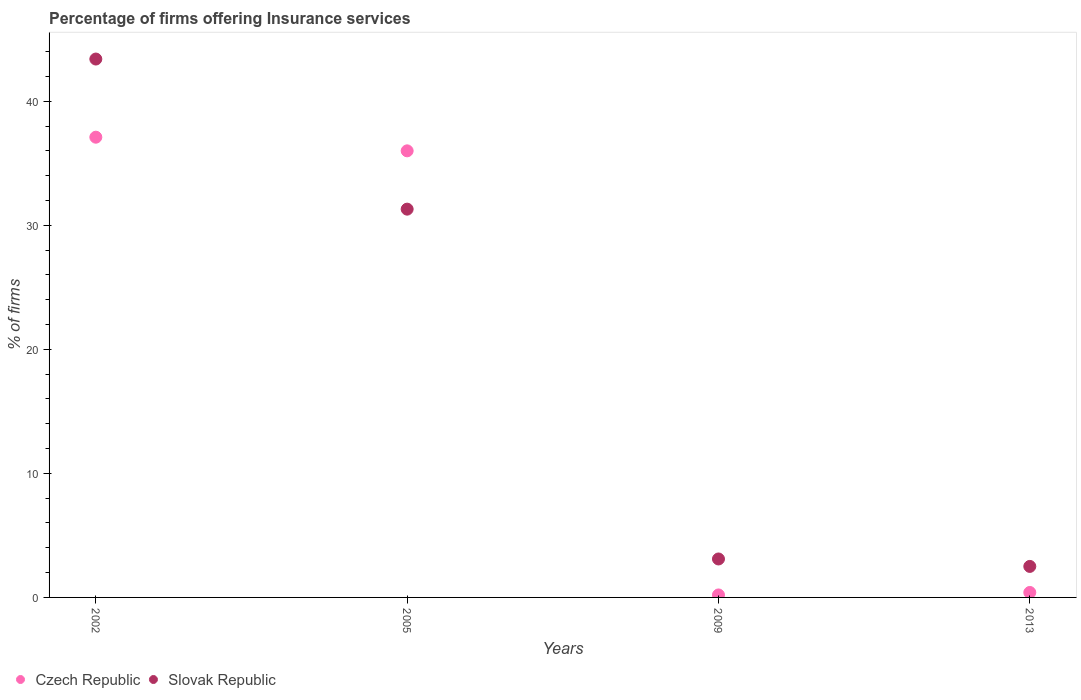Is the number of dotlines equal to the number of legend labels?
Ensure brevity in your answer.  Yes. What is the percentage of firms offering insurance services in Czech Republic in 2009?
Offer a terse response. 0.2. Across all years, what is the maximum percentage of firms offering insurance services in Czech Republic?
Make the answer very short. 37.1. Across all years, what is the minimum percentage of firms offering insurance services in Czech Republic?
Make the answer very short. 0.2. In which year was the percentage of firms offering insurance services in Czech Republic maximum?
Offer a terse response. 2002. What is the total percentage of firms offering insurance services in Slovak Republic in the graph?
Your answer should be very brief. 80.3. What is the difference between the percentage of firms offering insurance services in Slovak Republic in 2005 and the percentage of firms offering insurance services in Czech Republic in 2009?
Make the answer very short. 31.1. What is the average percentage of firms offering insurance services in Slovak Republic per year?
Provide a short and direct response. 20.07. In how many years, is the percentage of firms offering insurance services in Czech Republic greater than 20 %?
Offer a very short reply. 2. What is the ratio of the percentage of firms offering insurance services in Slovak Republic in 2002 to that in 2005?
Ensure brevity in your answer.  1.39. What is the difference between the highest and the second highest percentage of firms offering insurance services in Czech Republic?
Provide a short and direct response. 1.1. What is the difference between the highest and the lowest percentage of firms offering insurance services in Slovak Republic?
Ensure brevity in your answer.  40.9. In how many years, is the percentage of firms offering insurance services in Slovak Republic greater than the average percentage of firms offering insurance services in Slovak Republic taken over all years?
Offer a very short reply. 2. Is the sum of the percentage of firms offering insurance services in Slovak Republic in 2009 and 2013 greater than the maximum percentage of firms offering insurance services in Czech Republic across all years?
Keep it short and to the point. No. Does the percentage of firms offering insurance services in Slovak Republic monotonically increase over the years?
Give a very brief answer. No. Is the percentage of firms offering insurance services in Czech Republic strictly less than the percentage of firms offering insurance services in Slovak Republic over the years?
Provide a short and direct response. No. Does the graph contain any zero values?
Ensure brevity in your answer.  No. Does the graph contain grids?
Offer a terse response. No. How many legend labels are there?
Provide a succinct answer. 2. What is the title of the graph?
Provide a succinct answer. Percentage of firms offering Insurance services. What is the label or title of the X-axis?
Your answer should be compact. Years. What is the label or title of the Y-axis?
Provide a succinct answer. % of firms. What is the % of firms of Czech Republic in 2002?
Provide a short and direct response. 37.1. What is the % of firms of Slovak Republic in 2002?
Offer a very short reply. 43.4. What is the % of firms of Slovak Republic in 2005?
Your answer should be very brief. 31.3. What is the % of firms in Czech Republic in 2009?
Provide a succinct answer. 0.2. What is the % of firms in Slovak Republic in 2009?
Provide a short and direct response. 3.1. What is the % of firms of Slovak Republic in 2013?
Offer a terse response. 2.5. Across all years, what is the maximum % of firms of Czech Republic?
Provide a short and direct response. 37.1. Across all years, what is the maximum % of firms in Slovak Republic?
Ensure brevity in your answer.  43.4. Across all years, what is the minimum % of firms of Slovak Republic?
Provide a succinct answer. 2.5. What is the total % of firms of Czech Republic in the graph?
Your answer should be compact. 73.7. What is the total % of firms in Slovak Republic in the graph?
Your answer should be compact. 80.3. What is the difference between the % of firms of Slovak Republic in 2002 and that in 2005?
Your answer should be compact. 12.1. What is the difference between the % of firms in Czech Republic in 2002 and that in 2009?
Your answer should be compact. 36.9. What is the difference between the % of firms of Slovak Republic in 2002 and that in 2009?
Provide a short and direct response. 40.3. What is the difference between the % of firms of Czech Republic in 2002 and that in 2013?
Offer a terse response. 36.7. What is the difference between the % of firms in Slovak Republic in 2002 and that in 2013?
Ensure brevity in your answer.  40.9. What is the difference between the % of firms of Czech Republic in 2005 and that in 2009?
Provide a succinct answer. 35.8. What is the difference between the % of firms in Slovak Republic in 2005 and that in 2009?
Your answer should be compact. 28.2. What is the difference between the % of firms in Czech Republic in 2005 and that in 2013?
Provide a succinct answer. 35.6. What is the difference between the % of firms in Slovak Republic in 2005 and that in 2013?
Provide a succinct answer. 28.8. What is the difference between the % of firms in Czech Republic in 2002 and the % of firms in Slovak Republic in 2005?
Your answer should be very brief. 5.8. What is the difference between the % of firms of Czech Republic in 2002 and the % of firms of Slovak Republic in 2009?
Your response must be concise. 34. What is the difference between the % of firms of Czech Republic in 2002 and the % of firms of Slovak Republic in 2013?
Offer a very short reply. 34.6. What is the difference between the % of firms of Czech Republic in 2005 and the % of firms of Slovak Republic in 2009?
Offer a terse response. 32.9. What is the difference between the % of firms in Czech Republic in 2005 and the % of firms in Slovak Republic in 2013?
Give a very brief answer. 33.5. What is the average % of firms in Czech Republic per year?
Your answer should be compact. 18.43. What is the average % of firms of Slovak Republic per year?
Your answer should be very brief. 20.07. In the year 2002, what is the difference between the % of firms in Czech Republic and % of firms in Slovak Republic?
Offer a very short reply. -6.3. What is the ratio of the % of firms in Czech Republic in 2002 to that in 2005?
Your response must be concise. 1.03. What is the ratio of the % of firms of Slovak Republic in 2002 to that in 2005?
Provide a succinct answer. 1.39. What is the ratio of the % of firms in Czech Republic in 2002 to that in 2009?
Ensure brevity in your answer.  185.5. What is the ratio of the % of firms in Slovak Republic in 2002 to that in 2009?
Provide a succinct answer. 14. What is the ratio of the % of firms of Czech Republic in 2002 to that in 2013?
Keep it short and to the point. 92.75. What is the ratio of the % of firms in Slovak Republic in 2002 to that in 2013?
Provide a short and direct response. 17.36. What is the ratio of the % of firms of Czech Republic in 2005 to that in 2009?
Keep it short and to the point. 180. What is the ratio of the % of firms in Slovak Republic in 2005 to that in 2009?
Give a very brief answer. 10.1. What is the ratio of the % of firms in Czech Republic in 2005 to that in 2013?
Your response must be concise. 90. What is the ratio of the % of firms of Slovak Republic in 2005 to that in 2013?
Offer a terse response. 12.52. What is the ratio of the % of firms of Slovak Republic in 2009 to that in 2013?
Provide a short and direct response. 1.24. What is the difference between the highest and the second highest % of firms of Czech Republic?
Offer a very short reply. 1.1. What is the difference between the highest and the second highest % of firms in Slovak Republic?
Offer a terse response. 12.1. What is the difference between the highest and the lowest % of firms of Czech Republic?
Offer a very short reply. 36.9. What is the difference between the highest and the lowest % of firms in Slovak Republic?
Make the answer very short. 40.9. 